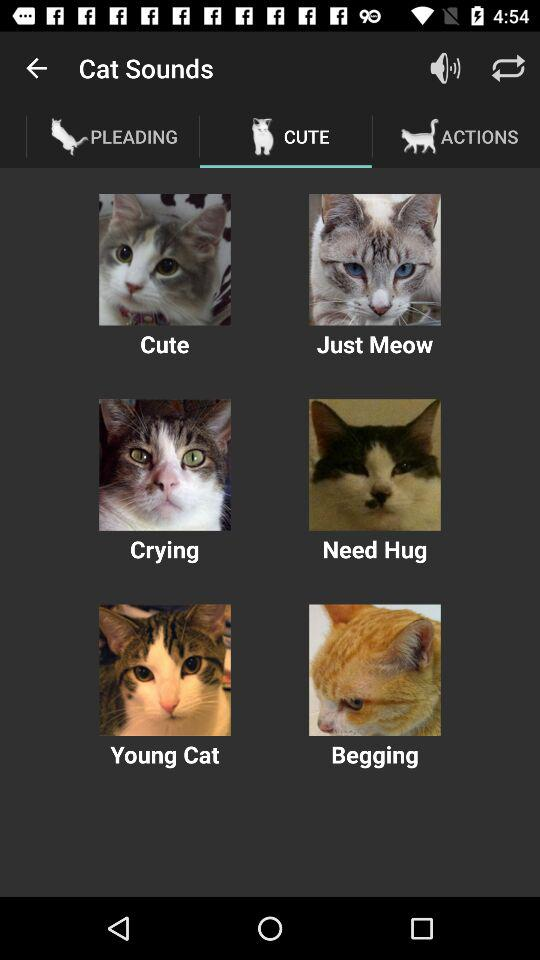Which tab is currently selected? The selected tab is "CUTE". 